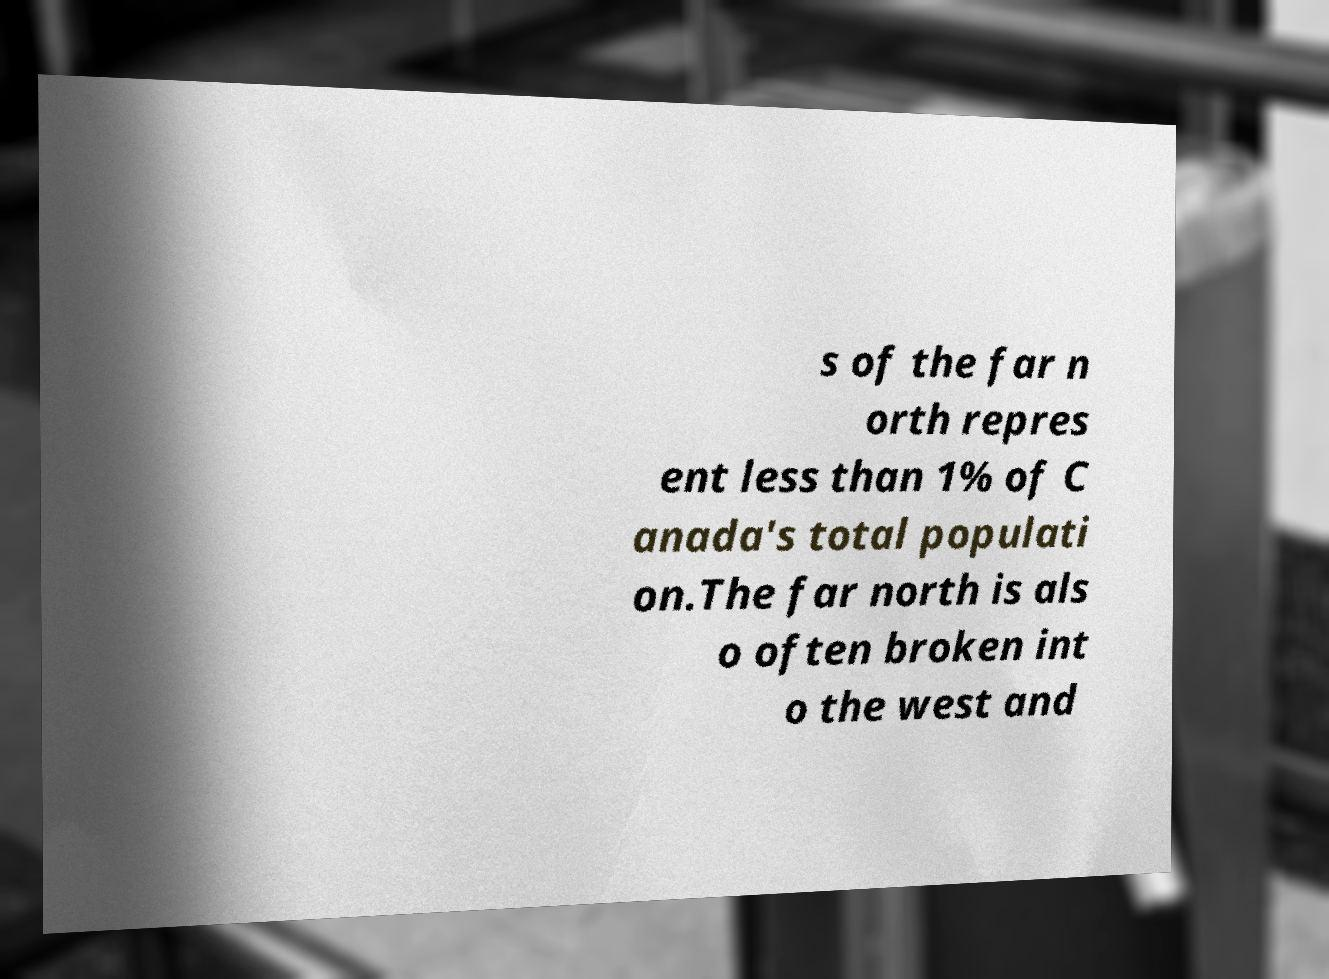For documentation purposes, I need the text within this image transcribed. Could you provide that? s of the far n orth repres ent less than 1% of C anada's total populati on.The far north is als o often broken int o the west and 